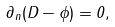<formula> <loc_0><loc_0><loc_500><loc_500>\partial _ { n } ( D - \phi ) = 0 ,</formula> 